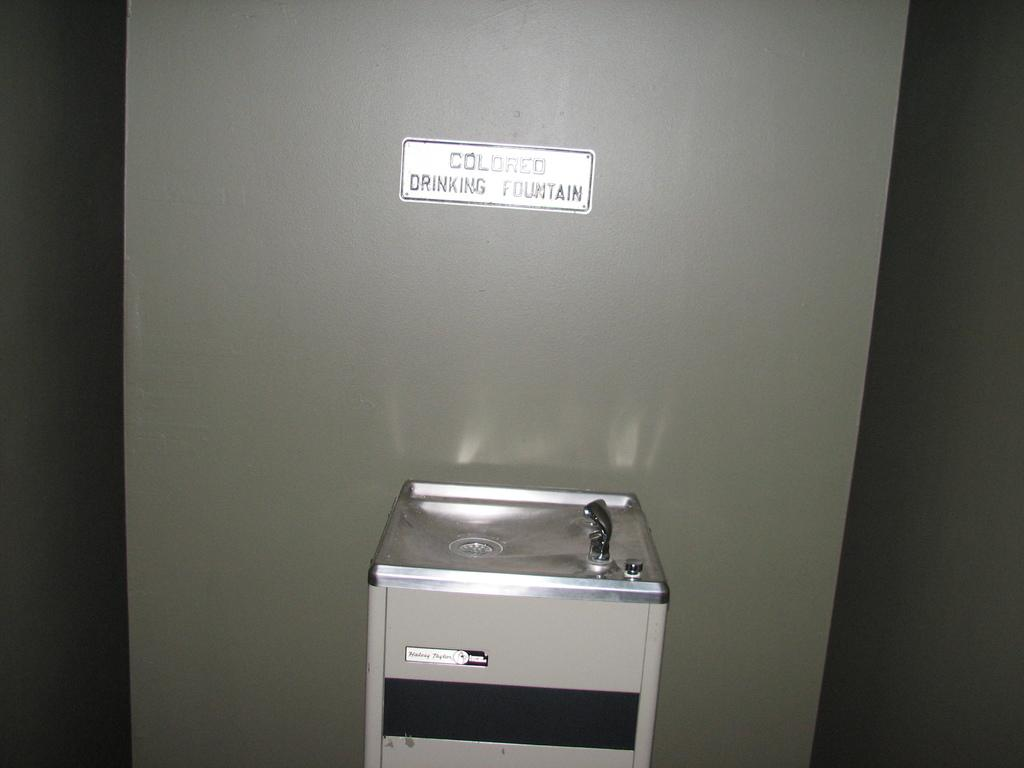What type of structure is present on the metal platform in the image? There is a sink with a tap on the metal platform in the image. What else can be seen on the metal platform? No other objects are mentioned on the metal platform, so we cannot provide additional information. What is attached to the wall in the background of the image? There is a board attached to the wall in the background of the image. How many cars are parked on the metal platform in the image? There are no cars present on the metal platform in the image. What time of day is depicted in the image, as indicated by the hour on the board? There is no mention of an hour or time of day on the board in the image. 